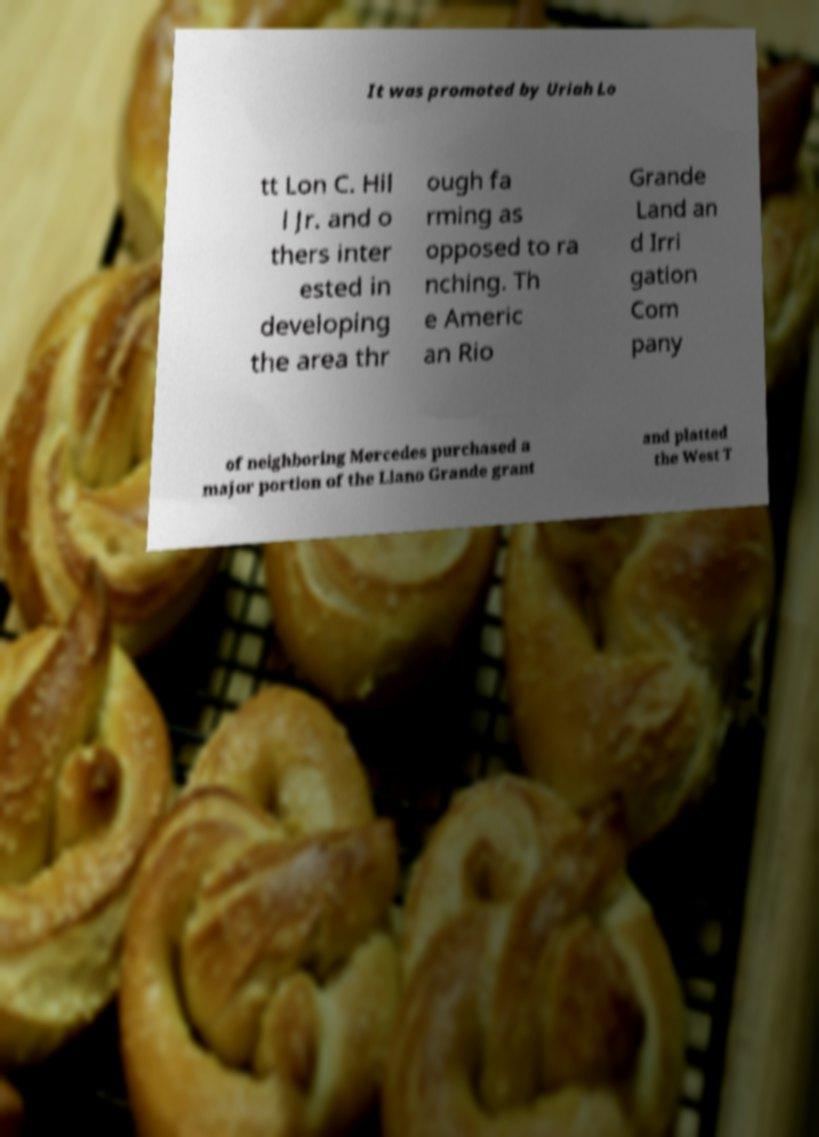What messages or text are displayed in this image? I need them in a readable, typed format. It was promoted by Uriah Lo tt Lon C. Hil l Jr. and o thers inter ested in developing the area thr ough fa rming as opposed to ra nching. Th e Americ an Rio Grande Land an d Irri gation Com pany of neighboring Mercedes purchased a major portion of the Llano Grande grant and platted the West T 